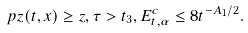<formula> <loc_0><loc_0><loc_500><loc_500>\ p { z ( t , x ) \geq z , \tau > t _ { 3 } , E _ { t , \alpha } ^ { c } } \leq 8 t ^ { - A _ { 1 } / 2 } .</formula> 